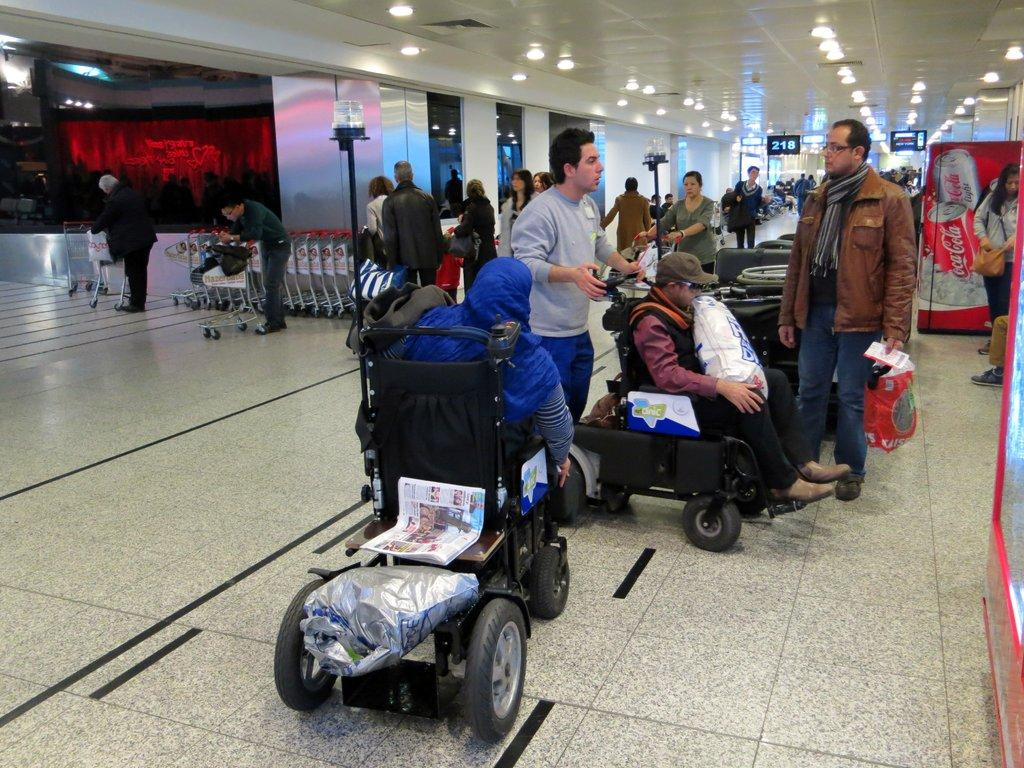<image>
Relay a brief, clear account of the picture shown. A building has a Coca Cola vending machine inside. 